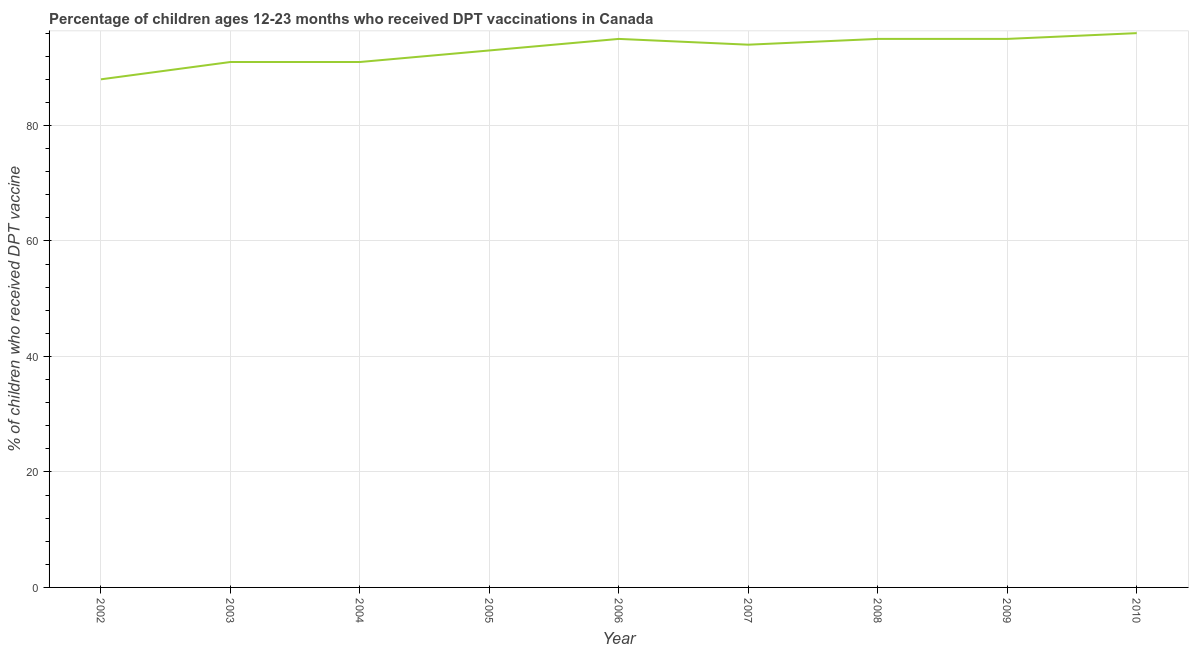What is the percentage of children who received dpt vaccine in 2009?
Give a very brief answer. 95. Across all years, what is the maximum percentage of children who received dpt vaccine?
Provide a succinct answer. 96. Across all years, what is the minimum percentage of children who received dpt vaccine?
Provide a succinct answer. 88. In which year was the percentage of children who received dpt vaccine minimum?
Ensure brevity in your answer.  2002. What is the sum of the percentage of children who received dpt vaccine?
Provide a short and direct response. 838. What is the difference between the percentage of children who received dpt vaccine in 2005 and 2010?
Offer a very short reply. -3. What is the average percentage of children who received dpt vaccine per year?
Ensure brevity in your answer.  93.11. What is the median percentage of children who received dpt vaccine?
Provide a short and direct response. 94. Do a majority of the years between 2004 and 2005 (inclusive) have percentage of children who received dpt vaccine greater than 64 %?
Your answer should be compact. Yes. What is the ratio of the percentage of children who received dpt vaccine in 2008 to that in 2010?
Make the answer very short. 0.99. Is the difference between the percentage of children who received dpt vaccine in 2006 and 2007 greater than the difference between any two years?
Make the answer very short. No. Is the sum of the percentage of children who received dpt vaccine in 2006 and 2008 greater than the maximum percentage of children who received dpt vaccine across all years?
Ensure brevity in your answer.  Yes. What is the difference between the highest and the lowest percentage of children who received dpt vaccine?
Provide a succinct answer. 8. Does the percentage of children who received dpt vaccine monotonically increase over the years?
Give a very brief answer. No. How many years are there in the graph?
Your response must be concise. 9. Does the graph contain any zero values?
Offer a very short reply. No. What is the title of the graph?
Make the answer very short. Percentage of children ages 12-23 months who received DPT vaccinations in Canada. What is the label or title of the X-axis?
Keep it short and to the point. Year. What is the label or title of the Y-axis?
Offer a very short reply. % of children who received DPT vaccine. What is the % of children who received DPT vaccine in 2002?
Offer a very short reply. 88. What is the % of children who received DPT vaccine of 2003?
Make the answer very short. 91. What is the % of children who received DPT vaccine in 2004?
Provide a succinct answer. 91. What is the % of children who received DPT vaccine of 2005?
Provide a succinct answer. 93. What is the % of children who received DPT vaccine in 2007?
Provide a short and direct response. 94. What is the % of children who received DPT vaccine in 2010?
Make the answer very short. 96. What is the difference between the % of children who received DPT vaccine in 2002 and 2003?
Ensure brevity in your answer.  -3. What is the difference between the % of children who received DPT vaccine in 2002 and 2004?
Give a very brief answer. -3. What is the difference between the % of children who received DPT vaccine in 2002 and 2005?
Offer a terse response. -5. What is the difference between the % of children who received DPT vaccine in 2002 and 2007?
Offer a terse response. -6. What is the difference between the % of children who received DPT vaccine in 2002 and 2008?
Make the answer very short. -7. What is the difference between the % of children who received DPT vaccine in 2002 and 2010?
Your response must be concise. -8. What is the difference between the % of children who received DPT vaccine in 2003 and 2004?
Ensure brevity in your answer.  0. What is the difference between the % of children who received DPT vaccine in 2003 and 2005?
Offer a terse response. -2. What is the difference between the % of children who received DPT vaccine in 2003 and 2006?
Provide a short and direct response. -4. What is the difference between the % of children who received DPT vaccine in 2003 and 2008?
Ensure brevity in your answer.  -4. What is the difference between the % of children who received DPT vaccine in 2003 and 2009?
Keep it short and to the point. -4. What is the difference between the % of children who received DPT vaccine in 2004 and 2005?
Offer a very short reply. -2. What is the difference between the % of children who received DPT vaccine in 2004 and 2006?
Ensure brevity in your answer.  -4. What is the difference between the % of children who received DPT vaccine in 2004 and 2007?
Offer a terse response. -3. What is the difference between the % of children who received DPT vaccine in 2004 and 2009?
Give a very brief answer. -4. What is the difference between the % of children who received DPT vaccine in 2004 and 2010?
Provide a succinct answer. -5. What is the difference between the % of children who received DPT vaccine in 2005 and 2008?
Offer a terse response. -2. What is the difference between the % of children who received DPT vaccine in 2005 and 2009?
Your answer should be compact. -2. What is the difference between the % of children who received DPT vaccine in 2007 and 2008?
Ensure brevity in your answer.  -1. What is the difference between the % of children who received DPT vaccine in 2007 and 2009?
Offer a very short reply. -1. What is the difference between the % of children who received DPT vaccine in 2007 and 2010?
Make the answer very short. -2. What is the difference between the % of children who received DPT vaccine in 2008 and 2009?
Keep it short and to the point. 0. What is the ratio of the % of children who received DPT vaccine in 2002 to that in 2003?
Your answer should be compact. 0.97. What is the ratio of the % of children who received DPT vaccine in 2002 to that in 2005?
Your response must be concise. 0.95. What is the ratio of the % of children who received DPT vaccine in 2002 to that in 2006?
Provide a short and direct response. 0.93. What is the ratio of the % of children who received DPT vaccine in 2002 to that in 2007?
Your answer should be compact. 0.94. What is the ratio of the % of children who received DPT vaccine in 2002 to that in 2008?
Offer a very short reply. 0.93. What is the ratio of the % of children who received DPT vaccine in 2002 to that in 2009?
Make the answer very short. 0.93. What is the ratio of the % of children who received DPT vaccine in 2002 to that in 2010?
Offer a very short reply. 0.92. What is the ratio of the % of children who received DPT vaccine in 2003 to that in 2004?
Provide a succinct answer. 1. What is the ratio of the % of children who received DPT vaccine in 2003 to that in 2006?
Give a very brief answer. 0.96. What is the ratio of the % of children who received DPT vaccine in 2003 to that in 2008?
Offer a very short reply. 0.96. What is the ratio of the % of children who received DPT vaccine in 2003 to that in 2009?
Provide a short and direct response. 0.96. What is the ratio of the % of children who received DPT vaccine in 2003 to that in 2010?
Provide a succinct answer. 0.95. What is the ratio of the % of children who received DPT vaccine in 2004 to that in 2006?
Provide a succinct answer. 0.96. What is the ratio of the % of children who received DPT vaccine in 2004 to that in 2008?
Ensure brevity in your answer.  0.96. What is the ratio of the % of children who received DPT vaccine in 2004 to that in 2009?
Provide a short and direct response. 0.96. What is the ratio of the % of children who received DPT vaccine in 2004 to that in 2010?
Make the answer very short. 0.95. What is the ratio of the % of children who received DPT vaccine in 2005 to that in 2008?
Your answer should be compact. 0.98. What is the ratio of the % of children who received DPT vaccine in 2005 to that in 2009?
Offer a terse response. 0.98. What is the ratio of the % of children who received DPT vaccine in 2006 to that in 2007?
Offer a terse response. 1.01. What is the ratio of the % of children who received DPT vaccine in 2006 to that in 2008?
Ensure brevity in your answer.  1. What is the ratio of the % of children who received DPT vaccine in 2006 to that in 2009?
Provide a succinct answer. 1. What is the ratio of the % of children who received DPT vaccine in 2006 to that in 2010?
Your answer should be very brief. 0.99. What is the ratio of the % of children who received DPT vaccine in 2007 to that in 2010?
Offer a terse response. 0.98. What is the ratio of the % of children who received DPT vaccine in 2008 to that in 2009?
Offer a terse response. 1. What is the ratio of the % of children who received DPT vaccine in 2008 to that in 2010?
Offer a terse response. 0.99. What is the ratio of the % of children who received DPT vaccine in 2009 to that in 2010?
Offer a terse response. 0.99. 